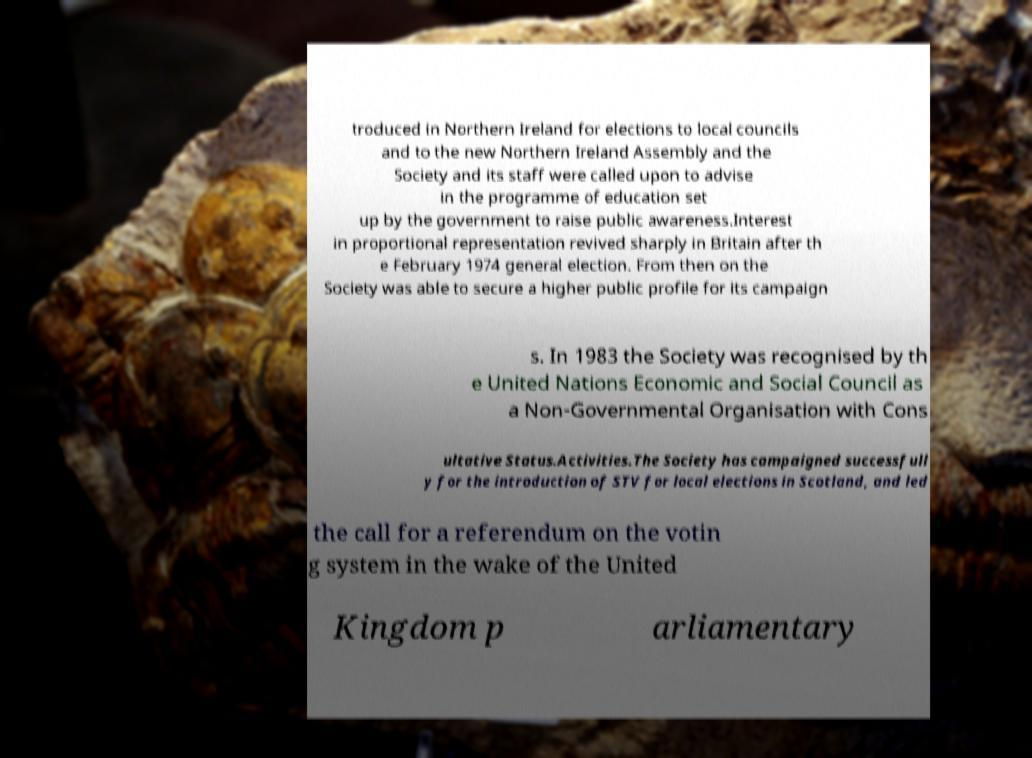Could you assist in decoding the text presented in this image and type it out clearly? troduced in Northern Ireland for elections to local councils and to the new Northern Ireland Assembly and the Society and its staff were called upon to advise in the programme of education set up by the government to raise public awareness.Interest in proportional representation revived sharply in Britain after th e February 1974 general election. From then on the Society was able to secure a higher public profile for its campaign s. In 1983 the Society was recognised by th e United Nations Economic and Social Council as a Non-Governmental Organisation with Cons ultative Status.Activities.The Society has campaigned successfull y for the introduction of STV for local elections in Scotland, and led the call for a referendum on the votin g system in the wake of the United Kingdom p arliamentary 